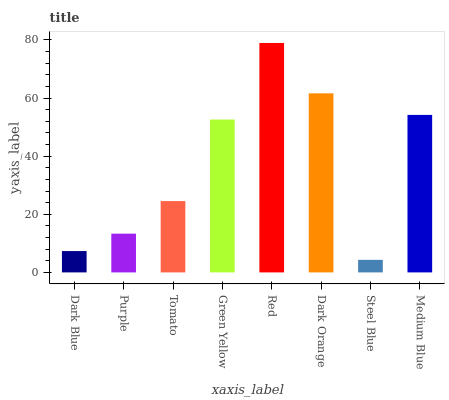Is Purple the minimum?
Answer yes or no. No. Is Purple the maximum?
Answer yes or no. No. Is Purple greater than Dark Blue?
Answer yes or no. Yes. Is Dark Blue less than Purple?
Answer yes or no. Yes. Is Dark Blue greater than Purple?
Answer yes or no. No. Is Purple less than Dark Blue?
Answer yes or no. No. Is Green Yellow the high median?
Answer yes or no. Yes. Is Tomato the low median?
Answer yes or no. Yes. Is Red the high median?
Answer yes or no. No. Is Purple the low median?
Answer yes or no. No. 